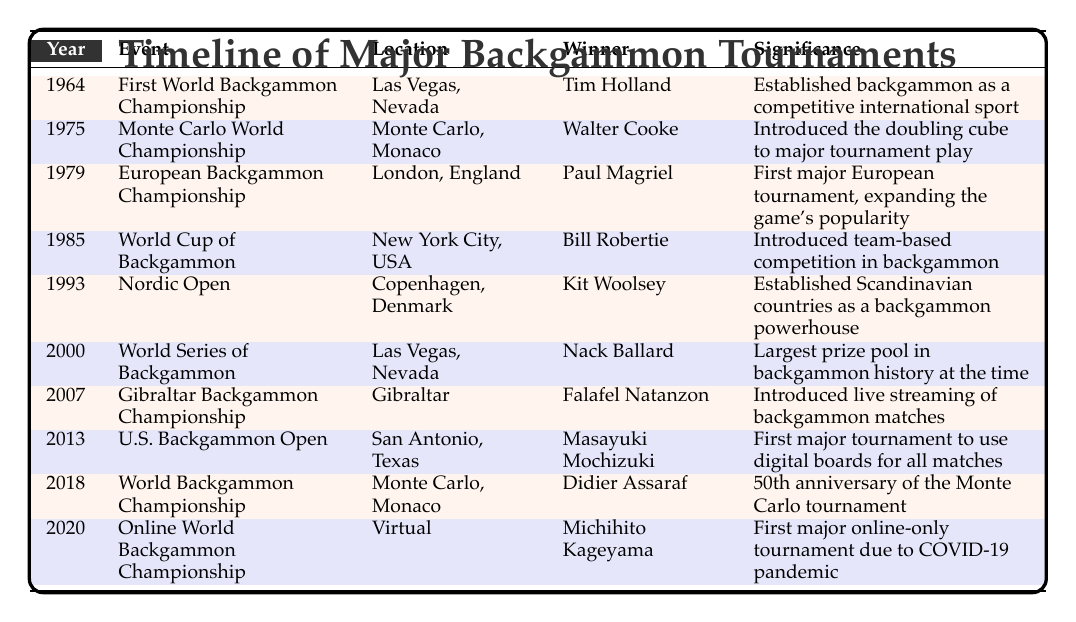What year was the first World Backgammon Championship held? The table lists the first World Backgammon Championship under the year 1964.
Answer: 1964 Who won the Monte Carlo World Championship in 1975? Looking at the year 1975 in the table, the winner listed for the Monte Carlo World Championship is Walter Cooke.
Answer: Walter Cooke How many tournaments took place before the year 2000? By counting the years in the table listed before 2000, there are six tournaments: 1964, 1975, 1979, 1985, 1993, and 1999.
Answer: 6 Was the introduction of digital boards noted in any tournament? Checking the table, the U.S. Backgammon Open in 2013 states it was the first major tournament to use digital boards for all matches, which confirms this fact.
Answer: Yes Which event had the largest prize pool at the time? The World Series of Backgammon in 2000 is noted in the significance column as having the largest prize pool in backgammon history at that time.
Answer: World Series of Backgammon In what location was the European Backgammon Championship held? The table shows that the European Backgammon Championship took place in London, England.
Answer: London, England What was significant about the 2018 World Backgammon Championship? The table states that the significance of the 2018 World Backgammon Championship was that it marked the 50th anniversary of the Monte Carlo tournament.
Answer: 50th anniversary of the Monte Carlo tournament How many tournaments listed involved virtual play? Observing the table, only one tournament, the Online World Backgammon Championship in 2020, was held in a virtual location. Therefore, the count is one.
Answer: 1 Who was the winner of the Nordic Open in 1993? According to the table, the winner of the Nordic Open in 1993 was Kit Woolsey.
Answer: Kit Woolsey 